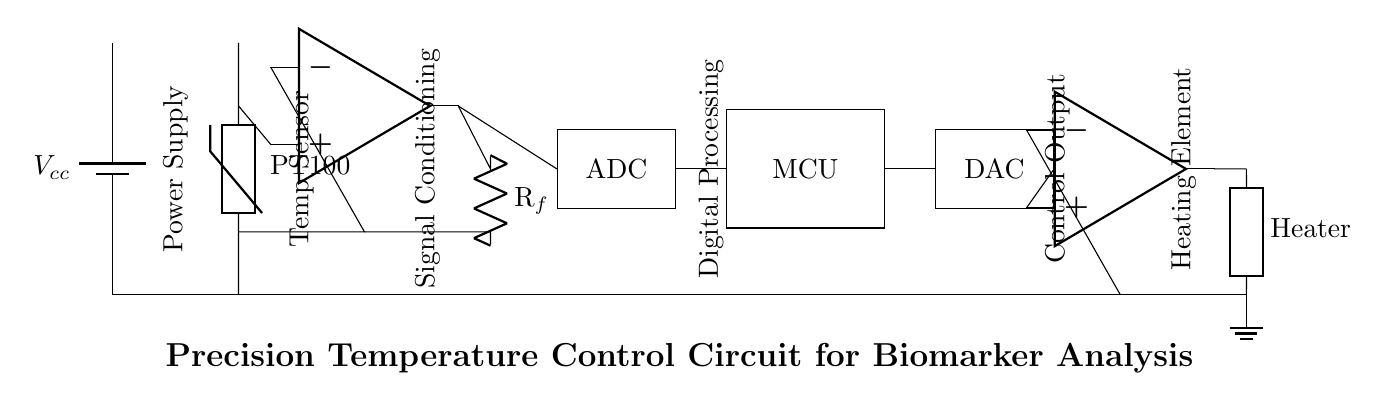What type of temperature sensor is used in this circuit? The circuit includes a PT100 temperature sensor, which is indicated in the diagram labeled as "PT100." This component is known for its accuracy and stability in temperature measurement.
Answer: PT100 What is the function of the operational amplifier in this circuit? The operational amplifier, labeled in the circuit as "op amp," is used for signal conditioning, amplifying the sensor output to a usable level for further processing. This is evident from its placement in the signal path between the temperature sensor and the ADC.
Answer: Signal conditioning How does the ADC contribute to the circuit's functionality? The ADC, located after the operational amplifier, converts the analog signal from the sensor into a digital format for processing by the microcontroller. This conversion is crucial for enabling digital computation based on the temperature readings.
Answer: Converts analog to digital What is the role of the microcontroller in this circuit? The microcontroller receives the digital signal from the ADC and processes it to determine the necessary control outputs for maintaining the desired temperature, making it a central component for controlling the heating element.
Answer: Control output computation Which component directly controls the heating element? The control output from the microcontroller is sent to the DAC, which converts that signal back to an analog format, controlling the power amplifier that manages the heating element. Thus, the power amplifier is the component that directly controls the heating element.
Answer: Power amplifier What is the type of the heating element used in this circuit? The heating element is labeled as "Heater" in the circuit diagram, and it is represented as a generic component. This indicates that it is a resistive heater providing heat for the temperature control application.
Answer: Heater What type of power supply is indicated in the circuit? A battery labeled as "Vcc" is used as the power supply for this circuit, providing the necessary voltage for the components to operate effectively, especially in a laboratory setting where stable power is crucial.
Answer: Battery 